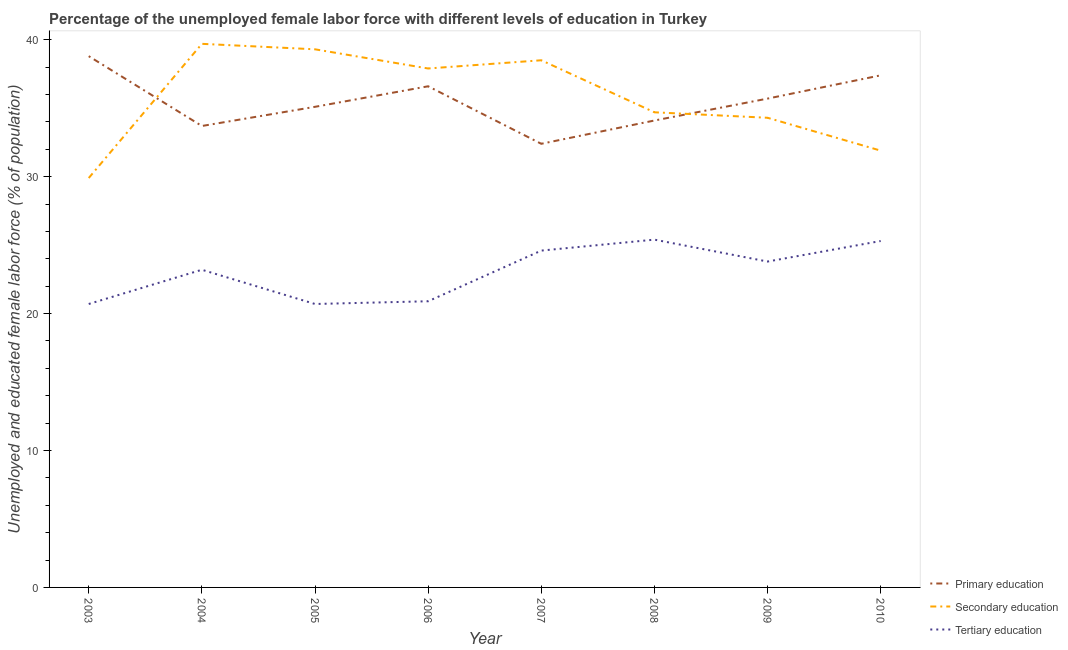How many different coloured lines are there?
Make the answer very short. 3. What is the percentage of female labor force who received secondary education in 2009?
Make the answer very short. 34.3. Across all years, what is the maximum percentage of female labor force who received secondary education?
Your answer should be very brief. 39.7. Across all years, what is the minimum percentage of female labor force who received tertiary education?
Provide a short and direct response. 20.7. In which year was the percentage of female labor force who received tertiary education minimum?
Offer a terse response. 2003. What is the total percentage of female labor force who received tertiary education in the graph?
Provide a succinct answer. 184.6. What is the difference between the percentage of female labor force who received tertiary education in 2005 and that in 2007?
Give a very brief answer. -3.9. What is the difference between the percentage of female labor force who received primary education in 2010 and the percentage of female labor force who received tertiary education in 2009?
Ensure brevity in your answer.  13.6. What is the average percentage of female labor force who received tertiary education per year?
Your answer should be very brief. 23.08. In the year 2008, what is the difference between the percentage of female labor force who received tertiary education and percentage of female labor force who received primary education?
Provide a short and direct response. -8.7. What is the ratio of the percentage of female labor force who received primary education in 2007 to that in 2009?
Your response must be concise. 0.91. Is the percentage of female labor force who received primary education in 2008 less than that in 2009?
Provide a succinct answer. Yes. Is the difference between the percentage of female labor force who received primary education in 2005 and 2009 greater than the difference between the percentage of female labor force who received tertiary education in 2005 and 2009?
Provide a short and direct response. Yes. What is the difference between the highest and the second highest percentage of female labor force who received secondary education?
Make the answer very short. 0.4. What is the difference between the highest and the lowest percentage of female labor force who received secondary education?
Your answer should be compact. 9.8. Is the sum of the percentage of female labor force who received primary education in 2003 and 2005 greater than the maximum percentage of female labor force who received secondary education across all years?
Your answer should be very brief. Yes. Is it the case that in every year, the sum of the percentage of female labor force who received primary education and percentage of female labor force who received secondary education is greater than the percentage of female labor force who received tertiary education?
Provide a succinct answer. Yes. Is the percentage of female labor force who received tertiary education strictly greater than the percentage of female labor force who received primary education over the years?
Make the answer very short. No. Is the percentage of female labor force who received secondary education strictly less than the percentage of female labor force who received primary education over the years?
Make the answer very short. No. How many lines are there?
Make the answer very short. 3. How many years are there in the graph?
Your response must be concise. 8. What is the difference between two consecutive major ticks on the Y-axis?
Your answer should be compact. 10. Does the graph contain grids?
Keep it short and to the point. No. Where does the legend appear in the graph?
Your answer should be compact. Bottom right. What is the title of the graph?
Offer a terse response. Percentage of the unemployed female labor force with different levels of education in Turkey. Does "Social Protection and Labor" appear as one of the legend labels in the graph?
Your response must be concise. No. What is the label or title of the Y-axis?
Your answer should be compact. Unemployed and educated female labor force (% of population). What is the Unemployed and educated female labor force (% of population) of Primary education in 2003?
Provide a short and direct response. 38.8. What is the Unemployed and educated female labor force (% of population) in Secondary education in 2003?
Make the answer very short. 29.9. What is the Unemployed and educated female labor force (% of population) of Tertiary education in 2003?
Make the answer very short. 20.7. What is the Unemployed and educated female labor force (% of population) of Primary education in 2004?
Your answer should be compact. 33.7. What is the Unemployed and educated female labor force (% of population) of Secondary education in 2004?
Offer a very short reply. 39.7. What is the Unemployed and educated female labor force (% of population) in Tertiary education in 2004?
Provide a succinct answer. 23.2. What is the Unemployed and educated female labor force (% of population) in Primary education in 2005?
Ensure brevity in your answer.  35.1. What is the Unemployed and educated female labor force (% of population) of Secondary education in 2005?
Make the answer very short. 39.3. What is the Unemployed and educated female labor force (% of population) of Tertiary education in 2005?
Provide a succinct answer. 20.7. What is the Unemployed and educated female labor force (% of population) of Primary education in 2006?
Your answer should be very brief. 36.6. What is the Unemployed and educated female labor force (% of population) of Secondary education in 2006?
Ensure brevity in your answer.  37.9. What is the Unemployed and educated female labor force (% of population) of Tertiary education in 2006?
Ensure brevity in your answer.  20.9. What is the Unemployed and educated female labor force (% of population) in Primary education in 2007?
Make the answer very short. 32.4. What is the Unemployed and educated female labor force (% of population) in Secondary education in 2007?
Offer a very short reply. 38.5. What is the Unemployed and educated female labor force (% of population) in Tertiary education in 2007?
Keep it short and to the point. 24.6. What is the Unemployed and educated female labor force (% of population) in Primary education in 2008?
Offer a very short reply. 34.1. What is the Unemployed and educated female labor force (% of population) in Secondary education in 2008?
Make the answer very short. 34.7. What is the Unemployed and educated female labor force (% of population) in Tertiary education in 2008?
Your response must be concise. 25.4. What is the Unemployed and educated female labor force (% of population) in Primary education in 2009?
Ensure brevity in your answer.  35.7. What is the Unemployed and educated female labor force (% of population) of Secondary education in 2009?
Offer a terse response. 34.3. What is the Unemployed and educated female labor force (% of population) in Tertiary education in 2009?
Your answer should be compact. 23.8. What is the Unemployed and educated female labor force (% of population) in Primary education in 2010?
Keep it short and to the point. 37.4. What is the Unemployed and educated female labor force (% of population) of Secondary education in 2010?
Your response must be concise. 31.9. What is the Unemployed and educated female labor force (% of population) of Tertiary education in 2010?
Give a very brief answer. 25.3. Across all years, what is the maximum Unemployed and educated female labor force (% of population) in Primary education?
Your response must be concise. 38.8. Across all years, what is the maximum Unemployed and educated female labor force (% of population) of Secondary education?
Offer a terse response. 39.7. Across all years, what is the maximum Unemployed and educated female labor force (% of population) in Tertiary education?
Offer a very short reply. 25.4. Across all years, what is the minimum Unemployed and educated female labor force (% of population) in Primary education?
Give a very brief answer. 32.4. Across all years, what is the minimum Unemployed and educated female labor force (% of population) in Secondary education?
Make the answer very short. 29.9. Across all years, what is the minimum Unemployed and educated female labor force (% of population) in Tertiary education?
Keep it short and to the point. 20.7. What is the total Unemployed and educated female labor force (% of population) of Primary education in the graph?
Offer a terse response. 283.8. What is the total Unemployed and educated female labor force (% of population) in Secondary education in the graph?
Your answer should be compact. 286.2. What is the total Unemployed and educated female labor force (% of population) of Tertiary education in the graph?
Make the answer very short. 184.6. What is the difference between the Unemployed and educated female labor force (% of population) of Tertiary education in 2003 and that in 2005?
Keep it short and to the point. 0. What is the difference between the Unemployed and educated female labor force (% of population) of Primary education in 2003 and that in 2006?
Make the answer very short. 2.2. What is the difference between the Unemployed and educated female labor force (% of population) in Primary education in 2003 and that in 2007?
Your response must be concise. 6.4. What is the difference between the Unemployed and educated female labor force (% of population) of Secondary education in 2003 and that in 2007?
Offer a very short reply. -8.6. What is the difference between the Unemployed and educated female labor force (% of population) in Tertiary education in 2003 and that in 2008?
Keep it short and to the point. -4.7. What is the difference between the Unemployed and educated female labor force (% of population) in Primary education in 2003 and that in 2009?
Your response must be concise. 3.1. What is the difference between the Unemployed and educated female labor force (% of population) of Secondary education in 2003 and that in 2009?
Make the answer very short. -4.4. What is the difference between the Unemployed and educated female labor force (% of population) of Tertiary education in 2003 and that in 2009?
Offer a terse response. -3.1. What is the difference between the Unemployed and educated female labor force (% of population) in Secondary education in 2003 and that in 2010?
Offer a very short reply. -2. What is the difference between the Unemployed and educated female labor force (% of population) in Tertiary education in 2003 and that in 2010?
Provide a short and direct response. -4.6. What is the difference between the Unemployed and educated female labor force (% of population) in Secondary education in 2004 and that in 2005?
Your answer should be very brief. 0.4. What is the difference between the Unemployed and educated female labor force (% of population) in Tertiary education in 2004 and that in 2005?
Give a very brief answer. 2.5. What is the difference between the Unemployed and educated female labor force (% of population) of Tertiary education in 2004 and that in 2006?
Offer a very short reply. 2.3. What is the difference between the Unemployed and educated female labor force (% of population) of Primary education in 2004 and that in 2007?
Your answer should be very brief. 1.3. What is the difference between the Unemployed and educated female labor force (% of population) of Primary education in 2004 and that in 2008?
Ensure brevity in your answer.  -0.4. What is the difference between the Unemployed and educated female labor force (% of population) in Secondary education in 2004 and that in 2009?
Your answer should be compact. 5.4. What is the difference between the Unemployed and educated female labor force (% of population) in Tertiary education in 2004 and that in 2009?
Give a very brief answer. -0.6. What is the difference between the Unemployed and educated female labor force (% of population) in Tertiary education in 2005 and that in 2007?
Your response must be concise. -3.9. What is the difference between the Unemployed and educated female labor force (% of population) in Primary education in 2005 and that in 2008?
Offer a very short reply. 1. What is the difference between the Unemployed and educated female labor force (% of population) of Secondary education in 2005 and that in 2008?
Your answer should be compact. 4.6. What is the difference between the Unemployed and educated female labor force (% of population) of Tertiary education in 2005 and that in 2008?
Ensure brevity in your answer.  -4.7. What is the difference between the Unemployed and educated female labor force (% of population) of Secondary education in 2005 and that in 2009?
Your response must be concise. 5. What is the difference between the Unemployed and educated female labor force (% of population) in Secondary education in 2005 and that in 2010?
Provide a short and direct response. 7.4. What is the difference between the Unemployed and educated female labor force (% of population) in Secondary education in 2006 and that in 2007?
Make the answer very short. -0.6. What is the difference between the Unemployed and educated female labor force (% of population) in Secondary education in 2006 and that in 2009?
Your response must be concise. 3.6. What is the difference between the Unemployed and educated female labor force (% of population) in Tertiary education in 2006 and that in 2010?
Ensure brevity in your answer.  -4.4. What is the difference between the Unemployed and educated female labor force (% of population) of Primary education in 2007 and that in 2009?
Your answer should be very brief. -3.3. What is the difference between the Unemployed and educated female labor force (% of population) of Secondary education in 2007 and that in 2010?
Offer a very short reply. 6.6. What is the difference between the Unemployed and educated female labor force (% of population) of Primary education in 2008 and that in 2009?
Give a very brief answer. -1.6. What is the difference between the Unemployed and educated female labor force (% of population) of Tertiary education in 2008 and that in 2009?
Provide a short and direct response. 1.6. What is the difference between the Unemployed and educated female labor force (% of population) in Secondary education in 2008 and that in 2010?
Give a very brief answer. 2.8. What is the difference between the Unemployed and educated female labor force (% of population) of Primary education in 2009 and that in 2010?
Your response must be concise. -1.7. What is the difference between the Unemployed and educated female labor force (% of population) of Secondary education in 2003 and the Unemployed and educated female labor force (% of population) of Tertiary education in 2004?
Your answer should be very brief. 6.7. What is the difference between the Unemployed and educated female labor force (% of population) in Primary education in 2003 and the Unemployed and educated female labor force (% of population) in Secondary education in 2005?
Offer a very short reply. -0.5. What is the difference between the Unemployed and educated female labor force (% of population) in Secondary education in 2003 and the Unemployed and educated female labor force (% of population) in Tertiary education in 2005?
Your answer should be very brief. 9.2. What is the difference between the Unemployed and educated female labor force (% of population) in Primary education in 2003 and the Unemployed and educated female labor force (% of population) in Tertiary education in 2007?
Give a very brief answer. 14.2. What is the difference between the Unemployed and educated female labor force (% of population) in Secondary education in 2003 and the Unemployed and educated female labor force (% of population) in Tertiary education in 2007?
Provide a short and direct response. 5.3. What is the difference between the Unemployed and educated female labor force (% of population) in Primary education in 2003 and the Unemployed and educated female labor force (% of population) in Tertiary education in 2008?
Provide a succinct answer. 13.4. What is the difference between the Unemployed and educated female labor force (% of population) of Secondary education in 2003 and the Unemployed and educated female labor force (% of population) of Tertiary education in 2008?
Give a very brief answer. 4.5. What is the difference between the Unemployed and educated female labor force (% of population) in Primary education in 2003 and the Unemployed and educated female labor force (% of population) in Secondary education in 2009?
Provide a short and direct response. 4.5. What is the difference between the Unemployed and educated female labor force (% of population) of Primary education in 2003 and the Unemployed and educated female labor force (% of population) of Secondary education in 2010?
Ensure brevity in your answer.  6.9. What is the difference between the Unemployed and educated female labor force (% of population) of Primary education in 2004 and the Unemployed and educated female labor force (% of population) of Secondary education in 2005?
Your response must be concise. -5.6. What is the difference between the Unemployed and educated female labor force (% of population) of Secondary education in 2004 and the Unemployed and educated female labor force (% of population) of Tertiary education in 2006?
Offer a terse response. 18.8. What is the difference between the Unemployed and educated female labor force (% of population) in Primary education in 2004 and the Unemployed and educated female labor force (% of population) in Tertiary education in 2007?
Keep it short and to the point. 9.1. What is the difference between the Unemployed and educated female labor force (% of population) in Primary education in 2004 and the Unemployed and educated female labor force (% of population) in Secondary education in 2009?
Ensure brevity in your answer.  -0.6. What is the difference between the Unemployed and educated female labor force (% of population) in Primary education in 2004 and the Unemployed and educated female labor force (% of population) in Tertiary education in 2009?
Your response must be concise. 9.9. What is the difference between the Unemployed and educated female labor force (% of population) in Secondary education in 2004 and the Unemployed and educated female labor force (% of population) in Tertiary education in 2009?
Offer a terse response. 15.9. What is the difference between the Unemployed and educated female labor force (% of population) of Primary education in 2004 and the Unemployed and educated female labor force (% of population) of Tertiary education in 2010?
Provide a short and direct response. 8.4. What is the difference between the Unemployed and educated female labor force (% of population) in Secondary education in 2004 and the Unemployed and educated female labor force (% of population) in Tertiary education in 2010?
Your answer should be compact. 14.4. What is the difference between the Unemployed and educated female labor force (% of population) of Primary education in 2005 and the Unemployed and educated female labor force (% of population) of Secondary education in 2006?
Give a very brief answer. -2.8. What is the difference between the Unemployed and educated female labor force (% of population) of Primary education in 2005 and the Unemployed and educated female labor force (% of population) of Tertiary education in 2006?
Your answer should be very brief. 14.2. What is the difference between the Unemployed and educated female labor force (% of population) in Secondary education in 2005 and the Unemployed and educated female labor force (% of population) in Tertiary education in 2006?
Keep it short and to the point. 18.4. What is the difference between the Unemployed and educated female labor force (% of population) of Secondary education in 2005 and the Unemployed and educated female labor force (% of population) of Tertiary education in 2009?
Your response must be concise. 15.5. What is the difference between the Unemployed and educated female labor force (% of population) in Secondary education in 2005 and the Unemployed and educated female labor force (% of population) in Tertiary education in 2010?
Provide a succinct answer. 14. What is the difference between the Unemployed and educated female labor force (% of population) of Primary education in 2006 and the Unemployed and educated female labor force (% of population) of Secondary education in 2007?
Offer a very short reply. -1.9. What is the difference between the Unemployed and educated female labor force (% of population) in Primary education in 2006 and the Unemployed and educated female labor force (% of population) in Tertiary education in 2007?
Your answer should be compact. 12. What is the difference between the Unemployed and educated female labor force (% of population) of Secondary education in 2006 and the Unemployed and educated female labor force (% of population) of Tertiary education in 2007?
Your answer should be compact. 13.3. What is the difference between the Unemployed and educated female labor force (% of population) of Primary education in 2006 and the Unemployed and educated female labor force (% of population) of Tertiary education in 2008?
Your answer should be compact. 11.2. What is the difference between the Unemployed and educated female labor force (% of population) in Primary education in 2006 and the Unemployed and educated female labor force (% of population) in Secondary education in 2009?
Ensure brevity in your answer.  2.3. What is the difference between the Unemployed and educated female labor force (% of population) in Primary education in 2006 and the Unemployed and educated female labor force (% of population) in Tertiary education in 2010?
Offer a terse response. 11.3. What is the difference between the Unemployed and educated female labor force (% of population) in Primary education in 2007 and the Unemployed and educated female labor force (% of population) in Tertiary education in 2008?
Your answer should be compact. 7. What is the difference between the Unemployed and educated female labor force (% of population) of Primary education in 2007 and the Unemployed and educated female labor force (% of population) of Secondary education in 2009?
Offer a very short reply. -1.9. What is the difference between the Unemployed and educated female labor force (% of population) in Secondary education in 2007 and the Unemployed and educated female labor force (% of population) in Tertiary education in 2009?
Your answer should be very brief. 14.7. What is the difference between the Unemployed and educated female labor force (% of population) of Secondary education in 2007 and the Unemployed and educated female labor force (% of population) of Tertiary education in 2010?
Provide a short and direct response. 13.2. What is the difference between the Unemployed and educated female labor force (% of population) of Primary education in 2008 and the Unemployed and educated female labor force (% of population) of Tertiary education in 2009?
Make the answer very short. 10.3. What is the difference between the Unemployed and educated female labor force (% of population) in Secondary education in 2008 and the Unemployed and educated female labor force (% of population) in Tertiary education in 2009?
Ensure brevity in your answer.  10.9. What is the difference between the Unemployed and educated female labor force (% of population) in Primary education in 2008 and the Unemployed and educated female labor force (% of population) in Secondary education in 2010?
Make the answer very short. 2.2. What is the difference between the Unemployed and educated female labor force (% of population) of Primary education in 2008 and the Unemployed and educated female labor force (% of population) of Tertiary education in 2010?
Give a very brief answer. 8.8. What is the difference between the Unemployed and educated female labor force (% of population) of Primary education in 2009 and the Unemployed and educated female labor force (% of population) of Secondary education in 2010?
Your answer should be compact. 3.8. What is the average Unemployed and educated female labor force (% of population) in Primary education per year?
Ensure brevity in your answer.  35.48. What is the average Unemployed and educated female labor force (% of population) in Secondary education per year?
Offer a very short reply. 35.77. What is the average Unemployed and educated female labor force (% of population) of Tertiary education per year?
Ensure brevity in your answer.  23.07. In the year 2004, what is the difference between the Unemployed and educated female labor force (% of population) of Primary education and Unemployed and educated female labor force (% of population) of Tertiary education?
Ensure brevity in your answer.  10.5. In the year 2005, what is the difference between the Unemployed and educated female labor force (% of population) in Primary education and Unemployed and educated female labor force (% of population) in Secondary education?
Your answer should be compact. -4.2. In the year 2005, what is the difference between the Unemployed and educated female labor force (% of population) of Primary education and Unemployed and educated female labor force (% of population) of Tertiary education?
Make the answer very short. 14.4. In the year 2006, what is the difference between the Unemployed and educated female labor force (% of population) of Primary education and Unemployed and educated female labor force (% of population) of Secondary education?
Your response must be concise. -1.3. In the year 2006, what is the difference between the Unemployed and educated female labor force (% of population) in Secondary education and Unemployed and educated female labor force (% of population) in Tertiary education?
Your answer should be compact. 17. In the year 2008, what is the difference between the Unemployed and educated female labor force (% of population) in Primary education and Unemployed and educated female labor force (% of population) in Secondary education?
Your response must be concise. -0.6. In the year 2008, what is the difference between the Unemployed and educated female labor force (% of population) of Primary education and Unemployed and educated female labor force (% of population) of Tertiary education?
Offer a terse response. 8.7. In the year 2009, what is the difference between the Unemployed and educated female labor force (% of population) of Primary education and Unemployed and educated female labor force (% of population) of Secondary education?
Provide a succinct answer. 1.4. In the year 2009, what is the difference between the Unemployed and educated female labor force (% of population) of Primary education and Unemployed and educated female labor force (% of population) of Tertiary education?
Offer a terse response. 11.9. In the year 2009, what is the difference between the Unemployed and educated female labor force (% of population) in Secondary education and Unemployed and educated female labor force (% of population) in Tertiary education?
Ensure brevity in your answer.  10.5. In the year 2010, what is the difference between the Unemployed and educated female labor force (% of population) of Primary education and Unemployed and educated female labor force (% of population) of Secondary education?
Provide a succinct answer. 5.5. What is the ratio of the Unemployed and educated female labor force (% of population) in Primary education in 2003 to that in 2004?
Ensure brevity in your answer.  1.15. What is the ratio of the Unemployed and educated female labor force (% of population) of Secondary education in 2003 to that in 2004?
Ensure brevity in your answer.  0.75. What is the ratio of the Unemployed and educated female labor force (% of population) in Tertiary education in 2003 to that in 2004?
Make the answer very short. 0.89. What is the ratio of the Unemployed and educated female labor force (% of population) of Primary education in 2003 to that in 2005?
Give a very brief answer. 1.11. What is the ratio of the Unemployed and educated female labor force (% of population) in Secondary education in 2003 to that in 2005?
Give a very brief answer. 0.76. What is the ratio of the Unemployed and educated female labor force (% of population) of Tertiary education in 2003 to that in 2005?
Offer a very short reply. 1. What is the ratio of the Unemployed and educated female labor force (% of population) of Primary education in 2003 to that in 2006?
Ensure brevity in your answer.  1.06. What is the ratio of the Unemployed and educated female labor force (% of population) in Secondary education in 2003 to that in 2006?
Make the answer very short. 0.79. What is the ratio of the Unemployed and educated female labor force (% of population) of Primary education in 2003 to that in 2007?
Your answer should be compact. 1.2. What is the ratio of the Unemployed and educated female labor force (% of population) of Secondary education in 2003 to that in 2007?
Your response must be concise. 0.78. What is the ratio of the Unemployed and educated female labor force (% of population) in Tertiary education in 2003 to that in 2007?
Your answer should be very brief. 0.84. What is the ratio of the Unemployed and educated female labor force (% of population) in Primary education in 2003 to that in 2008?
Your answer should be very brief. 1.14. What is the ratio of the Unemployed and educated female labor force (% of population) in Secondary education in 2003 to that in 2008?
Give a very brief answer. 0.86. What is the ratio of the Unemployed and educated female labor force (% of population) of Tertiary education in 2003 to that in 2008?
Your answer should be compact. 0.81. What is the ratio of the Unemployed and educated female labor force (% of population) of Primary education in 2003 to that in 2009?
Offer a very short reply. 1.09. What is the ratio of the Unemployed and educated female labor force (% of population) in Secondary education in 2003 to that in 2009?
Offer a terse response. 0.87. What is the ratio of the Unemployed and educated female labor force (% of population) in Tertiary education in 2003 to that in 2009?
Your answer should be compact. 0.87. What is the ratio of the Unemployed and educated female labor force (% of population) of Primary education in 2003 to that in 2010?
Provide a succinct answer. 1.04. What is the ratio of the Unemployed and educated female labor force (% of population) in Secondary education in 2003 to that in 2010?
Make the answer very short. 0.94. What is the ratio of the Unemployed and educated female labor force (% of population) in Tertiary education in 2003 to that in 2010?
Provide a succinct answer. 0.82. What is the ratio of the Unemployed and educated female labor force (% of population) of Primary education in 2004 to that in 2005?
Make the answer very short. 0.96. What is the ratio of the Unemployed and educated female labor force (% of population) in Secondary education in 2004 to that in 2005?
Offer a very short reply. 1.01. What is the ratio of the Unemployed and educated female labor force (% of population) of Tertiary education in 2004 to that in 2005?
Make the answer very short. 1.12. What is the ratio of the Unemployed and educated female labor force (% of population) of Primary education in 2004 to that in 2006?
Provide a succinct answer. 0.92. What is the ratio of the Unemployed and educated female labor force (% of population) of Secondary education in 2004 to that in 2006?
Give a very brief answer. 1.05. What is the ratio of the Unemployed and educated female labor force (% of population) of Tertiary education in 2004 to that in 2006?
Offer a terse response. 1.11. What is the ratio of the Unemployed and educated female labor force (% of population) in Primary education in 2004 to that in 2007?
Your response must be concise. 1.04. What is the ratio of the Unemployed and educated female labor force (% of population) in Secondary education in 2004 to that in 2007?
Your response must be concise. 1.03. What is the ratio of the Unemployed and educated female labor force (% of population) in Tertiary education in 2004 to that in 2007?
Make the answer very short. 0.94. What is the ratio of the Unemployed and educated female labor force (% of population) of Primary education in 2004 to that in 2008?
Offer a very short reply. 0.99. What is the ratio of the Unemployed and educated female labor force (% of population) in Secondary education in 2004 to that in 2008?
Your answer should be compact. 1.14. What is the ratio of the Unemployed and educated female labor force (% of population) in Tertiary education in 2004 to that in 2008?
Ensure brevity in your answer.  0.91. What is the ratio of the Unemployed and educated female labor force (% of population) in Primary education in 2004 to that in 2009?
Make the answer very short. 0.94. What is the ratio of the Unemployed and educated female labor force (% of population) of Secondary education in 2004 to that in 2009?
Offer a very short reply. 1.16. What is the ratio of the Unemployed and educated female labor force (% of population) in Tertiary education in 2004 to that in 2009?
Your answer should be compact. 0.97. What is the ratio of the Unemployed and educated female labor force (% of population) in Primary education in 2004 to that in 2010?
Ensure brevity in your answer.  0.9. What is the ratio of the Unemployed and educated female labor force (% of population) in Secondary education in 2004 to that in 2010?
Your answer should be compact. 1.24. What is the ratio of the Unemployed and educated female labor force (% of population) in Tertiary education in 2004 to that in 2010?
Provide a short and direct response. 0.92. What is the ratio of the Unemployed and educated female labor force (% of population) of Secondary education in 2005 to that in 2006?
Provide a short and direct response. 1.04. What is the ratio of the Unemployed and educated female labor force (% of population) in Primary education in 2005 to that in 2007?
Your answer should be compact. 1.08. What is the ratio of the Unemployed and educated female labor force (% of population) in Secondary education in 2005 to that in 2007?
Provide a short and direct response. 1.02. What is the ratio of the Unemployed and educated female labor force (% of population) of Tertiary education in 2005 to that in 2007?
Your response must be concise. 0.84. What is the ratio of the Unemployed and educated female labor force (% of population) of Primary education in 2005 to that in 2008?
Provide a succinct answer. 1.03. What is the ratio of the Unemployed and educated female labor force (% of population) in Secondary education in 2005 to that in 2008?
Provide a short and direct response. 1.13. What is the ratio of the Unemployed and educated female labor force (% of population) in Tertiary education in 2005 to that in 2008?
Give a very brief answer. 0.81. What is the ratio of the Unemployed and educated female labor force (% of population) of Primary education in 2005 to that in 2009?
Keep it short and to the point. 0.98. What is the ratio of the Unemployed and educated female labor force (% of population) in Secondary education in 2005 to that in 2009?
Offer a terse response. 1.15. What is the ratio of the Unemployed and educated female labor force (% of population) in Tertiary education in 2005 to that in 2009?
Offer a terse response. 0.87. What is the ratio of the Unemployed and educated female labor force (% of population) in Primary education in 2005 to that in 2010?
Make the answer very short. 0.94. What is the ratio of the Unemployed and educated female labor force (% of population) in Secondary education in 2005 to that in 2010?
Offer a terse response. 1.23. What is the ratio of the Unemployed and educated female labor force (% of population) in Tertiary education in 2005 to that in 2010?
Make the answer very short. 0.82. What is the ratio of the Unemployed and educated female labor force (% of population) of Primary education in 2006 to that in 2007?
Offer a very short reply. 1.13. What is the ratio of the Unemployed and educated female labor force (% of population) in Secondary education in 2006 to that in 2007?
Provide a short and direct response. 0.98. What is the ratio of the Unemployed and educated female labor force (% of population) in Tertiary education in 2006 to that in 2007?
Keep it short and to the point. 0.85. What is the ratio of the Unemployed and educated female labor force (% of population) of Primary education in 2006 to that in 2008?
Your answer should be compact. 1.07. What is the ratio of the Unemployed and educated female labor force (% of population) of Secondary education in 2006 to that in 2008?
Give a very brief answer. 1.09. What is the ratio of the Unemployed and educated female labor force (% of population) of Tertiary education in 2006 to that in 2008?
Provide a succinct answer. 0.82. What is the ratio of the Unemployed and educated female labor force (% of population) in Primary education in 2006 to that in 2009?
Provide a short and direct response. 1.03. What is the ratio of the Unemployed and educated female labor force (% of population) of Secondary education in 2006 to that in 2009?
Provide a succinct answer. 1.1. What is the ratio of the Unemployed and educated female labor force (% of population) in Tertiary education in 2006 to that in 2009?
Offer a very short reply. 0.88. What is the ratio of the Unemployed and educated female labor force (% of population) in Primary education in 2006 to that in 2010?
Keep it short and to the point. 0.98. What is the ratio of the Unemployed and educated female labor force (% of population) in Secondary education in 2006 to that in 2010?
Ensure brevity in your answer.  1.19. What is the ratio of the Unemployed and educated female labor force (% of population) of Tertiary education in 2006 to that in 2010?
Your response must be concise. 0.83. What is the ratio of the Unemployed and educated female labor force (% of population) in Primary education in 2007 to that in 2008?
Give a very brief answer. 0.95. What is the ratio of the Unemployed and educated female labor force (% of population) in Secondary education in 2007 to that in 2008?
Provide a short and direct response. 1.11. What is the ratio of the Unemployed and educated female labor force (% of population) of Tertiary education in 2007 to that in 2008?
Offer a very short reply. 0.97. What is the ratio of the Unemployed and educated female labor force (% of population) in Primary education in 2007 to that in 2009?
Offer a very short reply. 0.91. What is the ratio of the Unemployed and educated female labor force (% of population) of Secondary education in 2007 to that in 2009?
Your answer should be very brief. 1.12. What is the ratio of the Unemployed and educated female labor force (% of population) in Tertiary education in 2007 to that in 2009?
Your answer should be very brief. 1.03. What is the ratio of the Unemployed and educated female labor force (% of population) in Primary education in 2007 to that in 2010?
Give a very brief answer. 0.87. What is the ratio of the Unemployed and educated female labor force (% of population) in Secondary education in 2007 to that in 2010?
Provide a short and direct response. 1.21. What is the ratio of the Unemployed and educated female labor force (% of population) in Tertiary education in 2007 to that in 2010?
Your answer should be compact. 0.97. What is the ratio of the Unemployed and educated female labor force (% of population) of Primary education in 2008 to that in 2009?
Ensure brevity in your answer.  0.96. What is the ratio of the Unemployed and educated female labor force (% of population) of Secondary education in 2008 to that in 2009?
Offer a terse response. 1.01. What is the ratio of the Unemployed and educated female labor force (% of population) in Tertiary education in 2008 to that in 2009?
Provide a short and direct response. 1.07. What is the ratio of the Unemployed and educated female labor force (% of population) in Primary education in 2008 to that in 2010?
Make the answer very short. 0.91. What is the ratio of the Unemployed and educated female labor force (% of population) of Secondary education in 2008 to that in 2010?
Your answer should be very brief. 1.09. What is the ratio of the Unemployed and educated female labor force (% of population) of Primary education in 2009 to that in 2010?
Offer a terse response. 0.95. What is the ratio of the Unemployed and educated female labor force (% of population) of Secondary education in 2009 to that in 2010?
Your answer should be very brief. 1.08. What is the ratio of the Unemployed and educated female labor force (% of population) of Tertiary education in 2009 to that in 2010?
Provide a short and direct response. 0.94. What is the difference between the highest and the second highest Unemployed and educated female labor force (% of population) in Primary education?
Ensure brevity in your answer.  1.4. What is the difference between the highest and the second highest Unemployed and educated female labor force (% of population) in Secondary education?
Your answer should be very brief. 0.4. What is the difference between the highest and the lowest Unemployed and educated female labor force (% of population) in Secondary education?
Offer a very short reply. 9.8. 